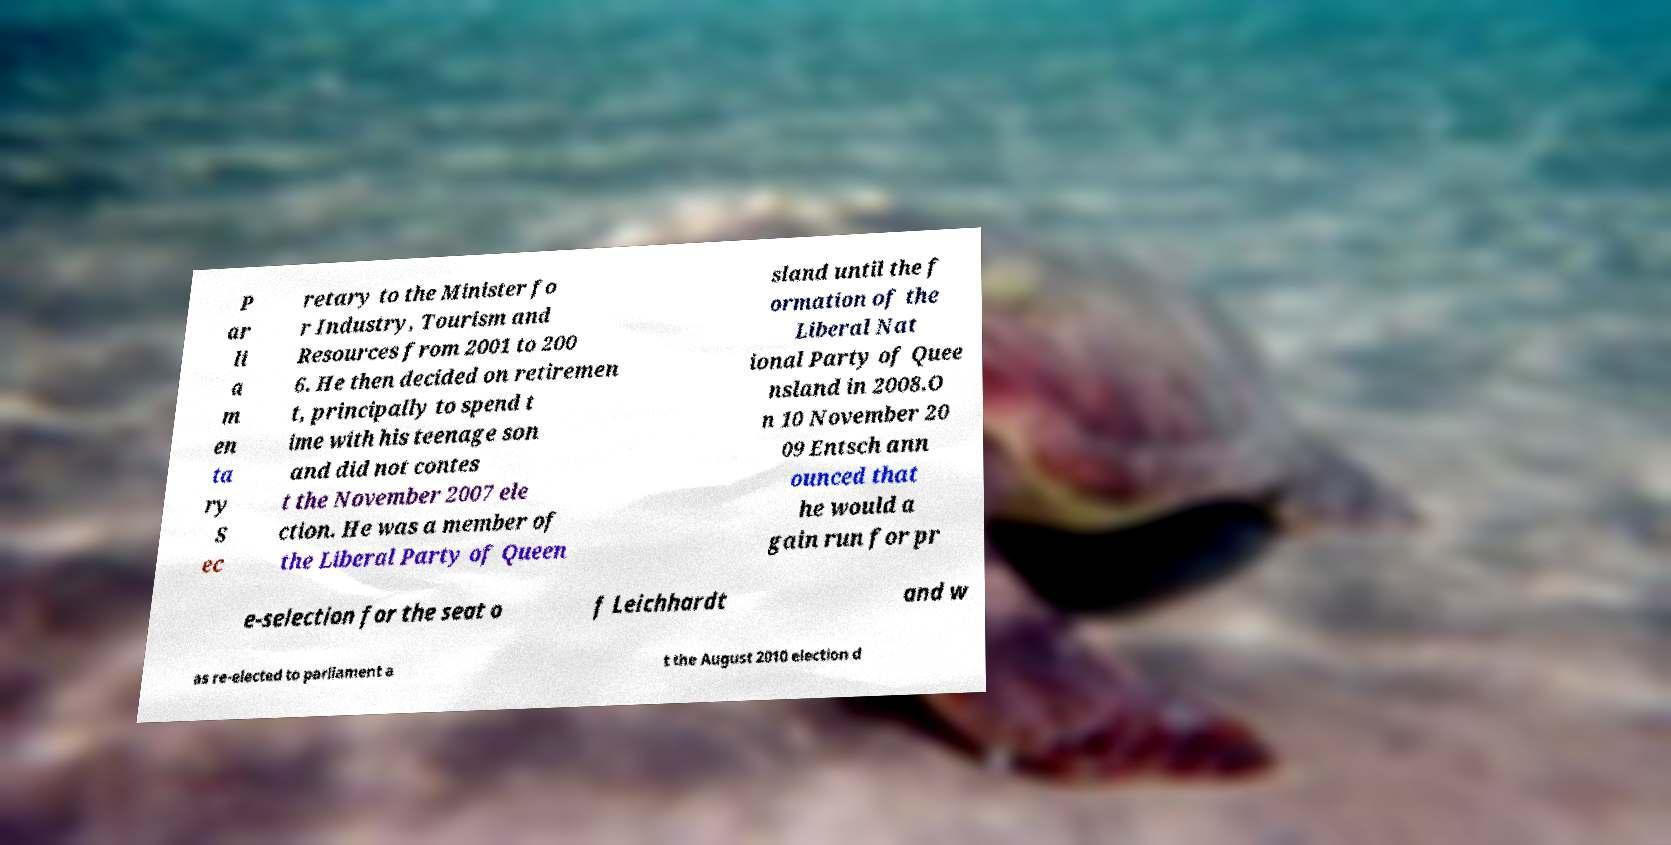Could you extract and type out the text from this image? P ar li a m en ta ry S ec retary to the Minister fo r Industry, Tourism and Resources from 2001 to 200 6. He then decided on retiremen t, principally to spend t ime with his teenage son and did not contes t the November 2007 ele ction. He was a member of the Liberal Party of Queen sland until the f ormation of the Liberal Nat ional Party of Quee nsland in 2008.O n 10 November 20 09 Entsch ann ounced that he would a gain run for pr e-selection for the seat o f Leichhardt and w as re-elected to parliament a t the August 2010 election d 